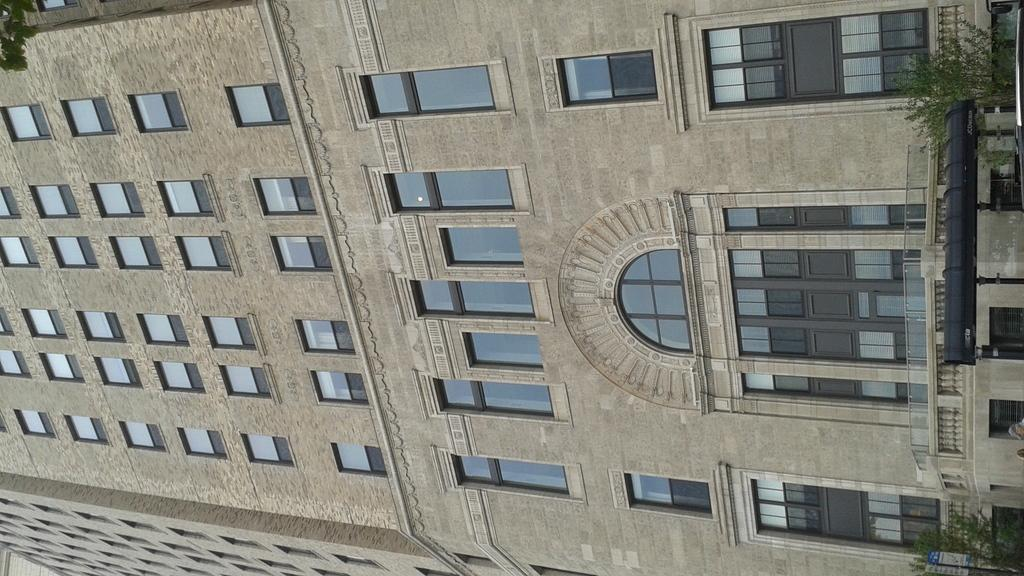What type of structure is visible in the image? There is a building in the image. What can be seen on the right side of the image? There are trees on the right side of the image, in front of the building. How many ants can be seen crawling on the disgusting ground in the image? There are no ants or any reference to the ground being disgusting in the image. 